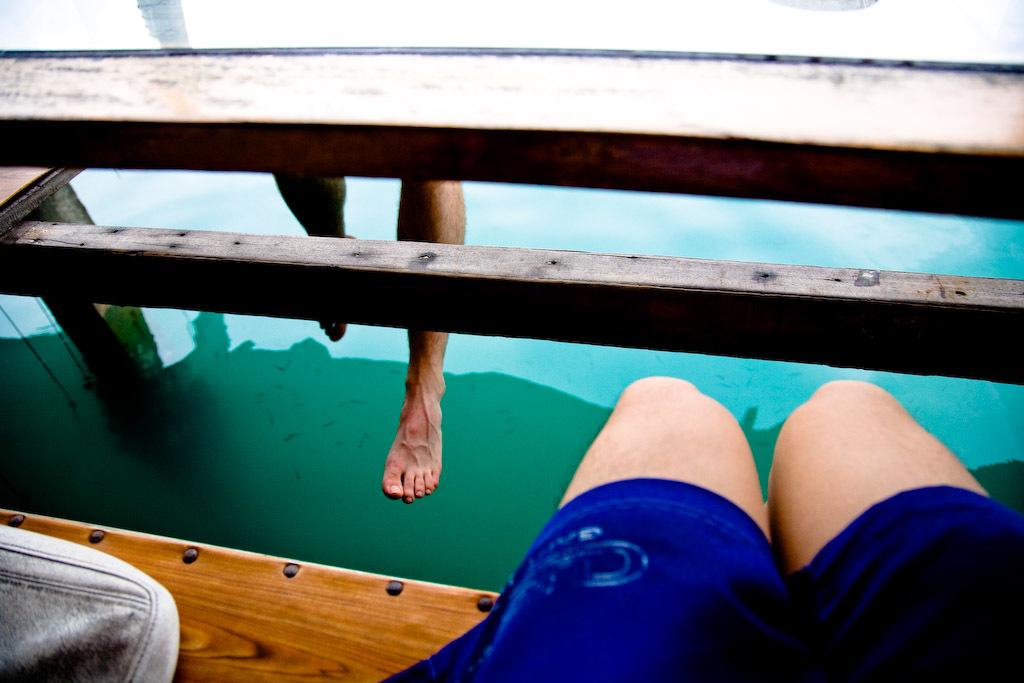What body parts are visible in the image? There are persons' legs visible in the image. What type of surface can be seen in the image? There is a wooden surface in the image. What type of yam is being played in rhythmic trouble in the image? There is no yam or any indication of trouble or rhythm in the image; it only shows persons' legs and a wooden surface. 